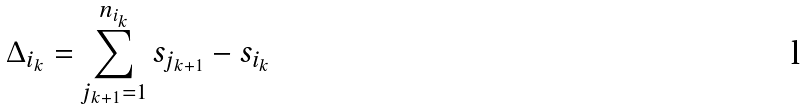Convert formula to latex. <formula><loc_0><loc_0><loc_500><loc_500>\Delta _ { i _ { k } } = \sum _ { j _ { k + 1 } = 1 } ^ { n _ { i _ { k } } } s _ { j _ { k + 1 } } - s _ { i _ { k } }</formula> 